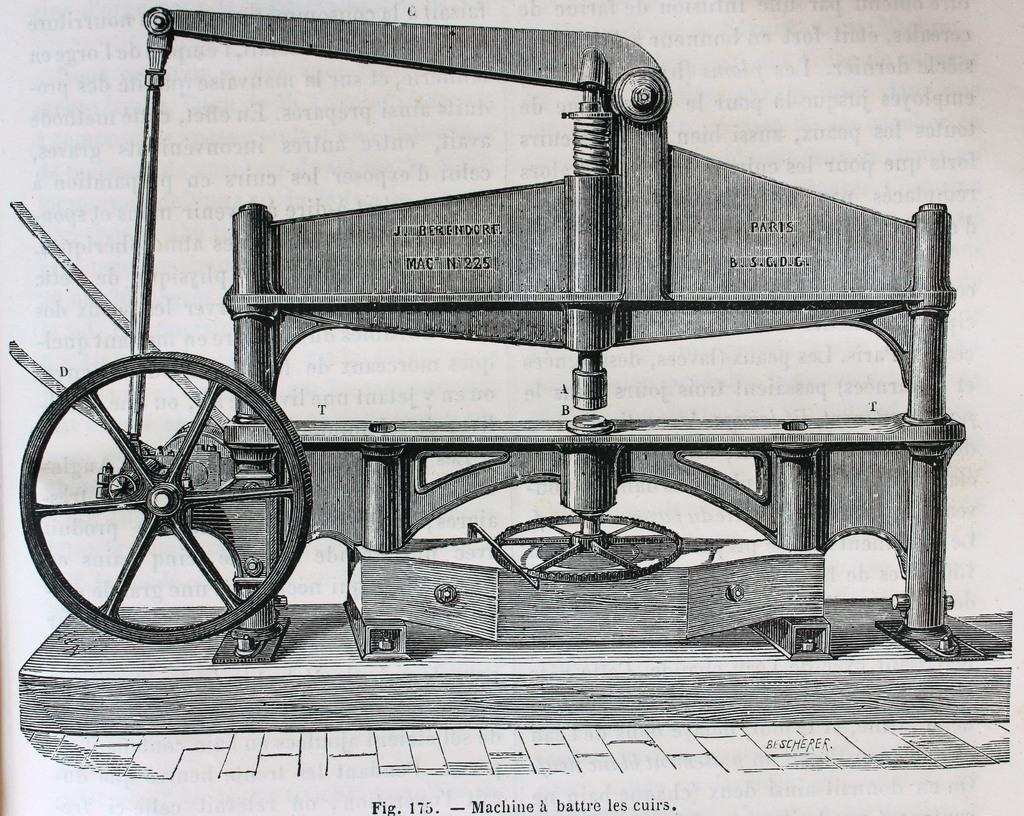What is the main subject of the image? The main subject of the image is a sketch of a machine. What else can be seen in the image besides the sketch? There is text in the image. What type of meal is being prepared in the image? There is no meal being prepared in the image; it features a sketch of a machine and text. What kind of trip is being planned in the image? There is no trip being planned in the image; it features a sketch of a machine and text. 